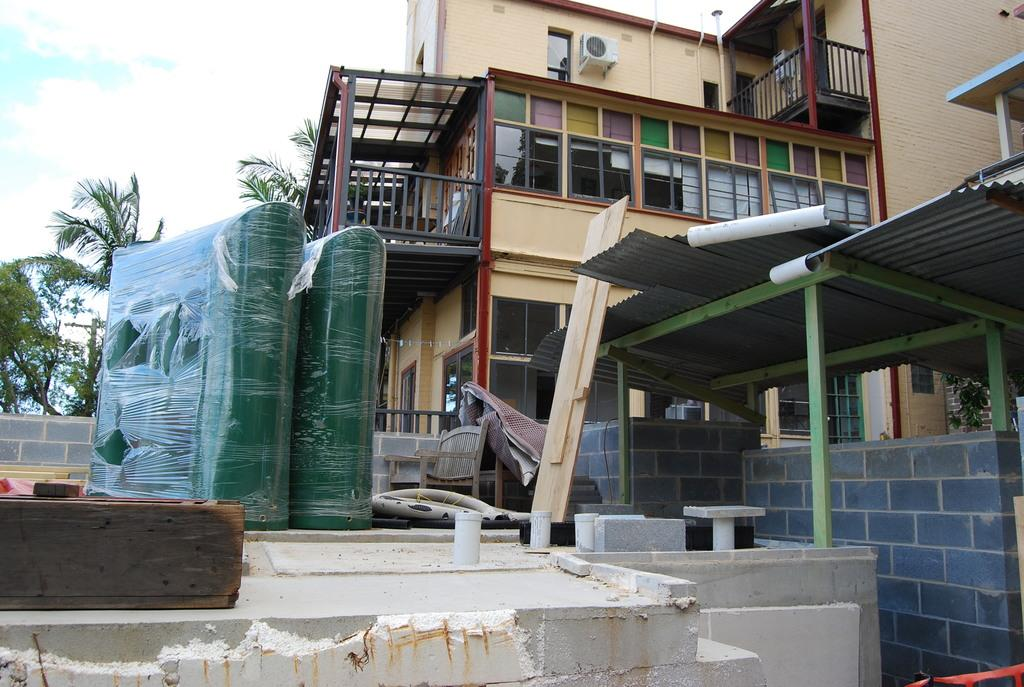What type of structure is visible in the image? There is a building in the image. What features can be observed on the building? The building has windows, a shelter, and walls. Are there any objects inside the building? There is a chair visible in the image. What type of appliance is present in the image? There is an air conditioning unit (AC) in the image. What type of natural elements can be seen in the image? There are trees and clouds visible in the image. What is visible in the background of the image? The sky is visible in the background of the image. Can you see a lawyer holding a gun in the image? There is no lawyer or gun present in the image. 